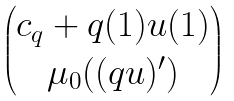Convert formula to latex. <formula><loc_0><loc_0><loc_500><loc_500>\begin{pmatrix} c _ { q } + q ( 1 ) u ( 1 ) \\ \mu _ { 0 } ( ( q u ) ^ { \prime } ) \end{pmatrix}</formula> 